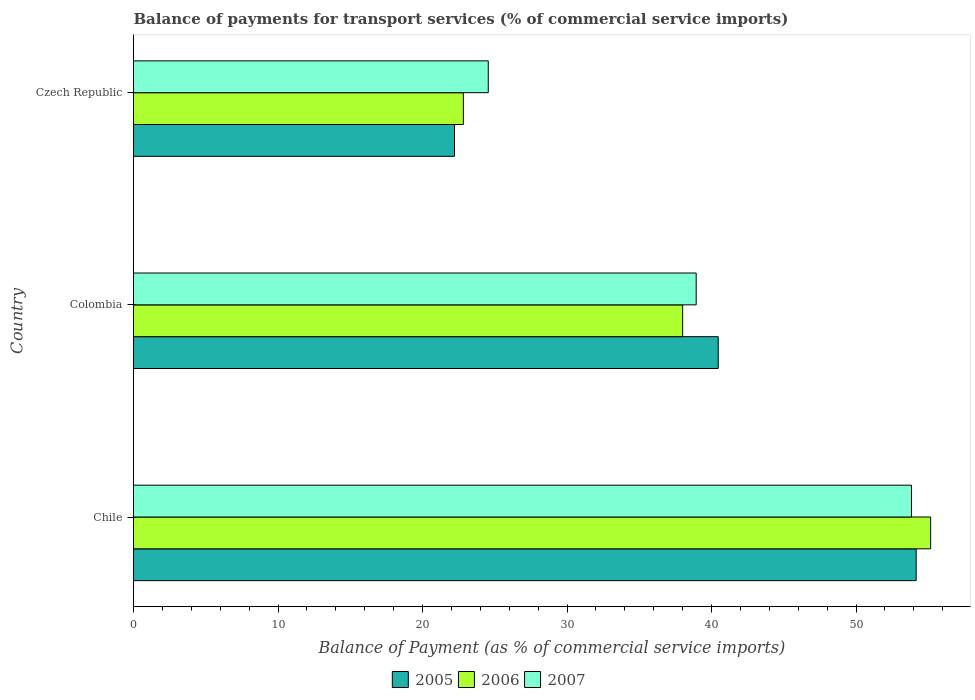Are the number of bars on each tick of the Y-axis equal?
Provide a succinct answer. Yes. How many bars are there on the 2nd tick from the top?
Give a very brief answer. 3. In how many cases, is the number of bars for a given country not equal to the number of legend labels?
Ensure brevity in your answer.  0. What is the balance of payments for transport services in 2005 in Czech Republic?
Offer a very short reply. 22.21. Across all countries, what is the maximum balance of payments for transport services in 2006?
Your answer should be very brief. 55.16. Across all countries, what is the minimum balance of payments for transport services in 2007?
Make the answer very short. 24.55. In which country was the balance of payments for transport services in 2006 minimum?
Give a very brief answer. Czech Republic. What is the total balance of payments for transport services in 2005 in the graph?
Provide a short and direct response. 116.83. What is the difference between the balance of payments for transport services in 2005 in Chile and that in Czech Republic?
Provide a succinct answer. 31.95. What is the difference between the balance of payments for transport services in 2007 in Czech Republic and the balance of payments for transport services in 2005 in Colombia?
Keep it short and to the point. -15.91. What is the average balance of payments for transport services in 2007 per country?
Give a very brief answer. 39.11. What is the difference between the balance of payments for transport services in 2006 and balance of payments for transport services in 2005 in Chile?
Ensure brevity in your answer.  1. What is the ratio of the balance of payments for transport services in 2005 in Colombia to that in Czech Republic?
Your response must be concise. 1.82. Is the balance of payments for transport services in 2006 in Chile less than that in Colombia?
Make the answer very short. No. Is the difference between the balance of payments for transport services in 2006 in Chile and Colombia greater than the difference between the balance of payments for transport services in 2005 in Chile and Colombia?
Ensure brevity in your answer.  Yes. What is the difference between the highest and the second highest balance of payments for transport services in 2006?
Offer a terse response. 17.16. What is the difference between the highest and the lowest balance of payments for transport services in 2007?
Give a very brief answer. 29.28. Is the sum of the balance of payments for transport services in 2006 in Colombia and Czech Republic greater than the maximum balance of payments for transport services in 2005 across all countries?
Keep it short and to the point. Yes. What does the 2nd bar from the top in Czech Republic represents?
Provide a short and direct response. 2006. How many legend labels are there?
Keep it short and to the point. 3. How are the legend labels stacked?
Keep it short and to the point. Horizontal. What is the title of the graph?
Provide a short and direct response. Balance of payments for transport services (% of commercial service imports). Does "1990" appear as one of the legend labels in the graph?
Your answer should be compact. No. What is the label or title of the X-axis?
Give a very brief answer. Balance of Payment (as % of commercial service imports). What is the Balance of Payment (as % of commercial service imports) in 2005 in Chile?
Offer a very short reply. 54.16. What is the Balance of Payment (as % of commercial service imports) in 2006 in Chile?
Offer a terse response. 55.16. What is the Balance of Payment (as % of commercial service imports) in 2007 in Chile?
Ensure brevity in your answer.  53.83. What is the Balance of Payment (as % of commercial service imports) of 2005 in Colombia?
Your answer should be compact. 40.46. What is the Balance of Payment (as % of commercial service imports) in 2006 in Colombia?
Your response must be concise. 38. What is the Balance of Payment (as % of commercial service imports) in 2007 in Colombia?
Your response must be concise. 38.94. What is the Balance of Payment (as % of commercial service imports) in 2005 in Czech Republic?
Your answer should be compact. 22.21. What is the Balance of Payment (as % of commercial service imports) in 2006 in Czech Republic?
Ensure brevity in your answer.  22.82. What is the Balance of Payment (as % of commercial service imports) in 2007 in Czech Republic?
Ensure brevity in your answer.  24.55. Across all countries, what is the maximum Balance of Payment (as % of commercial service imports) in 2005?
Make the answer very short. 54.16. Across all countries, what is the maximum Balance of Payment (as % of commercial service imports) in 2006?
Keep it short and to the point. 55.16. Across all countries, what is the maximum Balance of Payment (as % of commercial service imports) of 2007?
Keep it short and to the point. 53.83. Across all countries, what is the minimum Balance of Payment (as % of commercial service imports) of 2005?
Offer a terse response. 22.21. Across all countries, what is the minimum Balance of Payment (as % of commercial service imports) in 2006?
Make the answer very short. 22.82. Across all countries, what is the minimum Balance of Payment (as % of commercial service imports) of 2007?
Keep it short and to the point. 24.55. What is the total Balance of Payment (as % of commercial service imports) of 2005 in the graph?
Your answer should be compact. 116.83. What is the total Balance of Payment (as % of commercial service imports) in 2006 in the graph?
Keep it short and to the point. 115.99. What is the total Balance of Payment (as % of commercial service imports) of 2007 in the graph?
Your answer should be very brief. 117.32. What is the difference between the Balance of Payment (as % of commercial service imports) of 2005 in Chile and that in Colombia?
Your answer should be very brief. 13.7. What is the difference between the Balance of Payment (as % of commercial service imports) in 2006 in Chile and that in Colombia?
Give a very brief answer. 17.16. What is the difference between the Balance of Payment (as % of commercial service imports) of 2007 in Chile and that in Colombia?
Make the answer very short. 14.9. What is the difference between the Balance of Payment (as % of commercial service imports) of 2005 in Chile and that in Czech Republic?
Offer a very short reply. 31.95. What is the difference between the Balance of Payment (as % of commercial service imports) of 2006 in Chile and that in Czech Republic?
Provide a succinct answer. 32.34. What is the difference between the Balance of Payment (as % of commercial service imports) in 2007 in Chile and that in Czech Republic?
Offer a very short reply. 29.28. What is the difference between the Balance of Payment (as % of commercial service imports) of 2005 in Colombia and that in Czech Republic?
Your response must be concise. 18.25. What is the difference between the Balance of Payment (as % of commercial service imports) of 2006 in Colombia and that in Czech Republic?
Ensure brevity in your answer.  15.18. What is the difference between the Balance of Payment (as % of commercial service imports) in 2007 in Colombia and that in Czech Republic?
Ensure brevity in your answer.  14.39. What is the difference between the Balance of Payment (as % of commercial service imports) in 2005 in Chile and the Balance of Payment (as % of commercial service imports) in 2006 in Colombia?
Your answer should be compact. 16.16. What is the difference between the Balance of Payment (as % of commercial service imports) of 2005 in Chile and the Balance of Payment (as % of commercial service imports) of 2007 in Colombia?
Keep it short and to the point. 15.22. What is the difference between the Balance of Payment (as % of commercial service imports) of 2006 in Chile and the Balance of Payment (as % of commercial service imports) of 2007 in Colombia?
Your answer should be compact. 16.22. What is the difference between the Balance of Payment (as % of commercial service imports) of 2005 in Chile and the Balance of Payment (as % of commercial service imports) of 2006 in Czech Republic?
Provide a short and direct response. 31.34. What is the difference between the Balance of Payment (as % of commercial service imports) in 2005 in Chile and the Balance of Payment (as % of commercial service imports) in 2007 in Czech Republic?
Make the answer very short. 29.61. What is the difference between the Balance of Payment (as % of commercial service imports) in 2006 in Chile and the Balance of Payment (as % of commercial service imports) in 2007 in Czech Republic?
Ensure brevity in your answer.  30.61. What is the difference between the Balance of Payment (as % of commercial service imports) in 2005 in Colombia and the Balance of Payment (as % of commercial service imports) in 2006 in Czech Republic?
Make the answer very short. 17.64. What is the difference between the Balance of Payment (as % of commercial service imports) of 2005 in Colombia and the Balance of Payment (as % of commercial service imports) of 2007 in Czech Republic?
Keep it short and to the point. 15.91. What is the difference between the Balance of Payment (as % of commercial service imports) in 2006 in Colombia and the Balance of Payment (as % of commercial service imports) in 2007 in Czech Republic?
Your answer should be very brief. 13.45. What is the average Balance of Payment (as % of commercial service imports) in 2005 per country?
Provide a succinct answer. 38.94. What is the average Balance of Payment (as % of commercial service imports) of 2006 per country?
Give a very brief answer. 38.66. What is the average Balance of Payment (as % of commercial service imports) in 2007 per country?
Offer a terse response. 39.11. What is the difference between the Balance of Payment (as % of commercial service imports) in 2005 and Balance of Payment (as % of commercial service imports) in 2006 in Chile?
Ensure brevity in your answer.  -1. What is the difference between the Balance of Payment (as % of commercial service imports) in 2005 and Balance of Payment (as % of commercial service imports) in 2007 in Chile?
Give a very brief answer. 0.33. What is the difference between the Balance of Payment (as % of commercial service imports) in 2006 and Balance of Payment (as % of commercial service imports) in 2007 in Chile?
Keep it short and to the point. 1.33. What is the difference between the Balance of Payment (as % of commercial service imports) of 2005 and Balance of Payment (as % of commercial service imports) of 2006 in Colombia?
Your response must be concise. 2.46. What is the difference between the Balance of Payment (as % of commercial service imports) of 2005 and Balance of Payment (as % of commercial service imports) of 2007 in Colombia?
Give a very brief answer. 1.52. What is the difference between the Balance of Payment (as % of commercial service imports) of 2006 and Balance of Payment (as % of commercial service imports) of 2007 in Colombia?
Ensure brevity in your answer.  -0.94. What is the difference between the Balance of Payment (as % of commercial service imports) of 2005 and Balance of Payment (as % of commercial service imports) of 2006 in Czech Republic?
Your answer should be very brief. -0.61. What is the difference between the Balance of Payment (as % of commercial service imports) in 2005 and Balance of Payment (as % of commercial service imports) in 2007 in Czech Republic?
Give a very brief answer. -2.34. What is the difference between the Balance of Payment (as % of commercial service imports) of 2006 and Balance of Payment (as % of commercial service imports) of 2007 in Czech Republic?
Provide a short and direct response. -1.72. What is the ratio of the Balance of Payment (as % of commercial service imports) of 2005 in Chile to that in Colombia?
Give a very brief answer. 1.34. What is the ratio of the Balance of Payment (as % of commercial service imports) in 2006 in Chile to that in Colombia?
Ensure brevity in your answer.  1.45. What is the ratio of the Balance of Payment (as % of commercial service imports) of 2007 in Chile to that in Colombia?
Provide a short and direct response. 1.38. What is the ratio of the Balance of Payment (as % of commercial service imports) of 2005 in Chile to that in Czech Republic?
Your answer should be compact. 2.44. What is the ratio of the Balance of Payment (as % of commercial service imports) in 2006 in Chile to that in Czech Republic?
Offer a very short reply. 2.42. What is the ratio of the Balance of Payment (as % of commercial service imports) in 2007 in Chile to that in Czech Republic?
Provide a succinct answer. 2.19. What is the ratio of the Balance of Payment (as % of commercial service imports) of 2005 in Colombia to that in Czech Republic?
Keep it short and to the point. 1.82. What is the ratio of the Balance of Payment (as % of commercial service imports) in 2006 in Colombia to that in Czech Republic?
Your response must be concise. 1.66. What is the ratio of the Balance of Payment (as % of commercial service imports) in 2007 in Colombia to that in Czech Republic?
Make the answer very short. 1.59. What is the difference between the highest and the second highest Balance of Payment (as % of commercial service imports) in 2005?
Ensure brevity in your answer.  13.7. What is the difference between the highest and the second highest Balance of Payment (as % of commercial service imports) of 2006?
Give a very brief answer. 17.16. What is the difference between the highest and the second highest Balance of Payment (as % of commercial service imports) of 2007?
Offer a very short reply. 14.9. What is the difference between the highest and the lowest Balance of Payment (as % of commercial service imports) of 2005?
Your response must be concise. 31.95. What is the difference between the highest and the lowest Balance of Payment (as % of commercial service imports) of 2006?
Provide a short and direct response. 32.34. What is the difference between the highest and the lowest Balance of Payment (as % of commercial service imports) of 2007?
Make the answer very short. 29.28. 